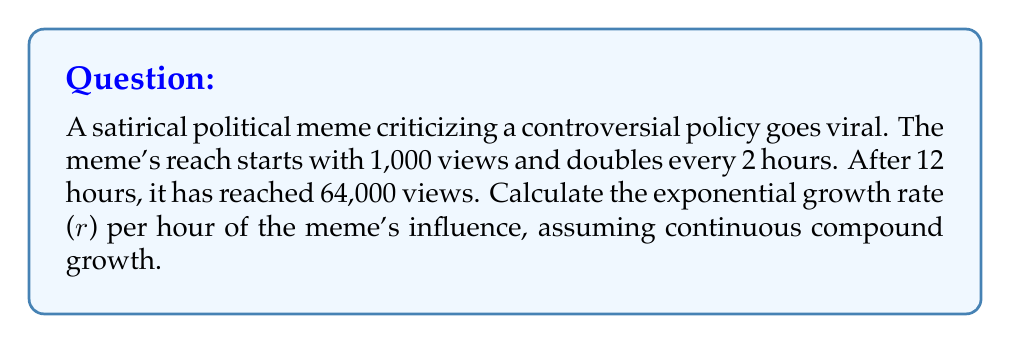Give your solution to this math problem. Let's approach this step-by-step:

1) The general formula for exponential growth is:

   $A(t) = A_0 e^{rt}$

   Where:
   $A(t)$ is the amount at time $t$
   $A_0$ is the initial amount
   $r$ is the growth rate
   $t$ is the time

2) We know:
   $A_0 = 1,000$ (initial views)
   $A(12) = 64,000$ (views after 12 hours)
   $t = 12$ hours

3) Plugging these into our formula:

   $64,000 = 1,000 e^{12r}$

4) Divide both sides by 1,000:

   $64 = e^{12r}$

5) Take the natural log of both sides:

   $\ln(64) = 12r$

6) Solve for $r$:

   $r = \frac{\ln(64)}{12}$

7) Calculate:

   $r = \frac{4.1588833}{12} \approx 0.3465736$ per hour

This rate represents the continuous compound growth rate per hour.
Answer: $r \approx 0.3466$ per hour 